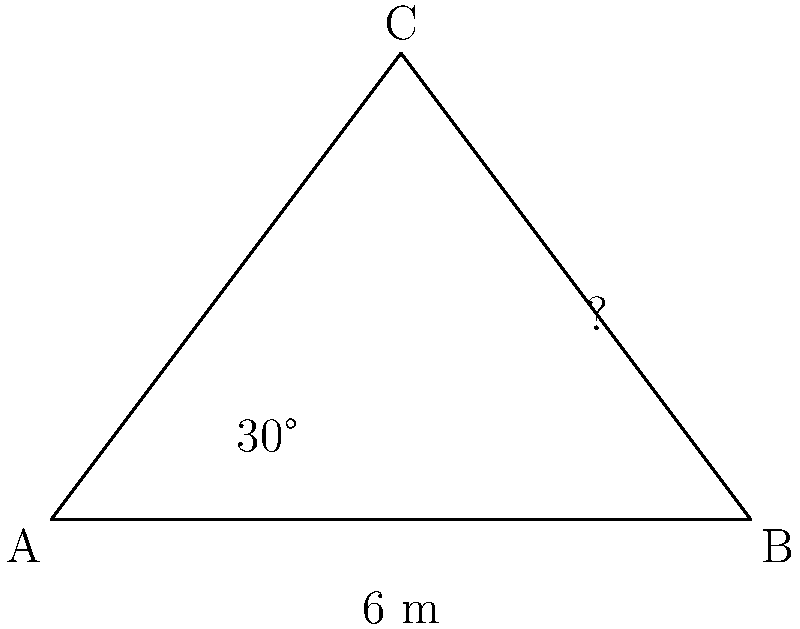At a crime scene, tire tracks form a triangle with two known sides. The base of the triangle (distance between two fixed points) is 6 meters, and one angle at the base is 30°. If the height of the triangle (perpendicular distance from the apex to the base) is 4 meters, what is the angle of the suspect's escape path relative to the base? To solve this problem, we'll use trigonometry and the properties of right triangles. Let's break it down step by step:

1) First, we identify that we have a right triangle within our main triangle. The height forms the perpendicular side of this right triangle.

2) We know the height (4 m) and one angle (30°) of this right triangle.

3) Using the tangent function, we can find the length of the side adjacent to the 30° angle:

   $$\tan(30°) = \frac{\text{opposite}}{\text{adjacent}} = \frac{4}{\text{adjacent}}$$

4) Solving for the adjacent side:

   $$\text{adjacent} = \frac{4}{\tan(30°)} \approx 6.93 \text{ m}$$

5) Now we know two sides of the main triangle: the base (6 m) and the side we just calculated (6.93 m).

6) We can use the law of cosines to find the angle we're looking for. Let's call this angle θ.

   $$\cos(θ) = \frac{6^2 + 6.93^2 - x^2}{2(6)(6.93)}$$

   Where x is the third side of the triangle, which we can calculate using the Pythagorean theorem:

   $$x^2 = 6.93^2 + 4^2 = 64.1249$$

7) Plugging this into our law of cosines equation:

   $$\cos(θ) = \frac{36 + 48.0249 - 64.1249}{83.16} = 0.2402$$

8) Taking the inverse cosine (arccos) of both sides:

   $$θ = \arccos(0.2402) \approx 76.1°$$

Therefore, the angle of the suspect's escape path relative to the base is approximately 76.1°.
Answer: 76.1° 